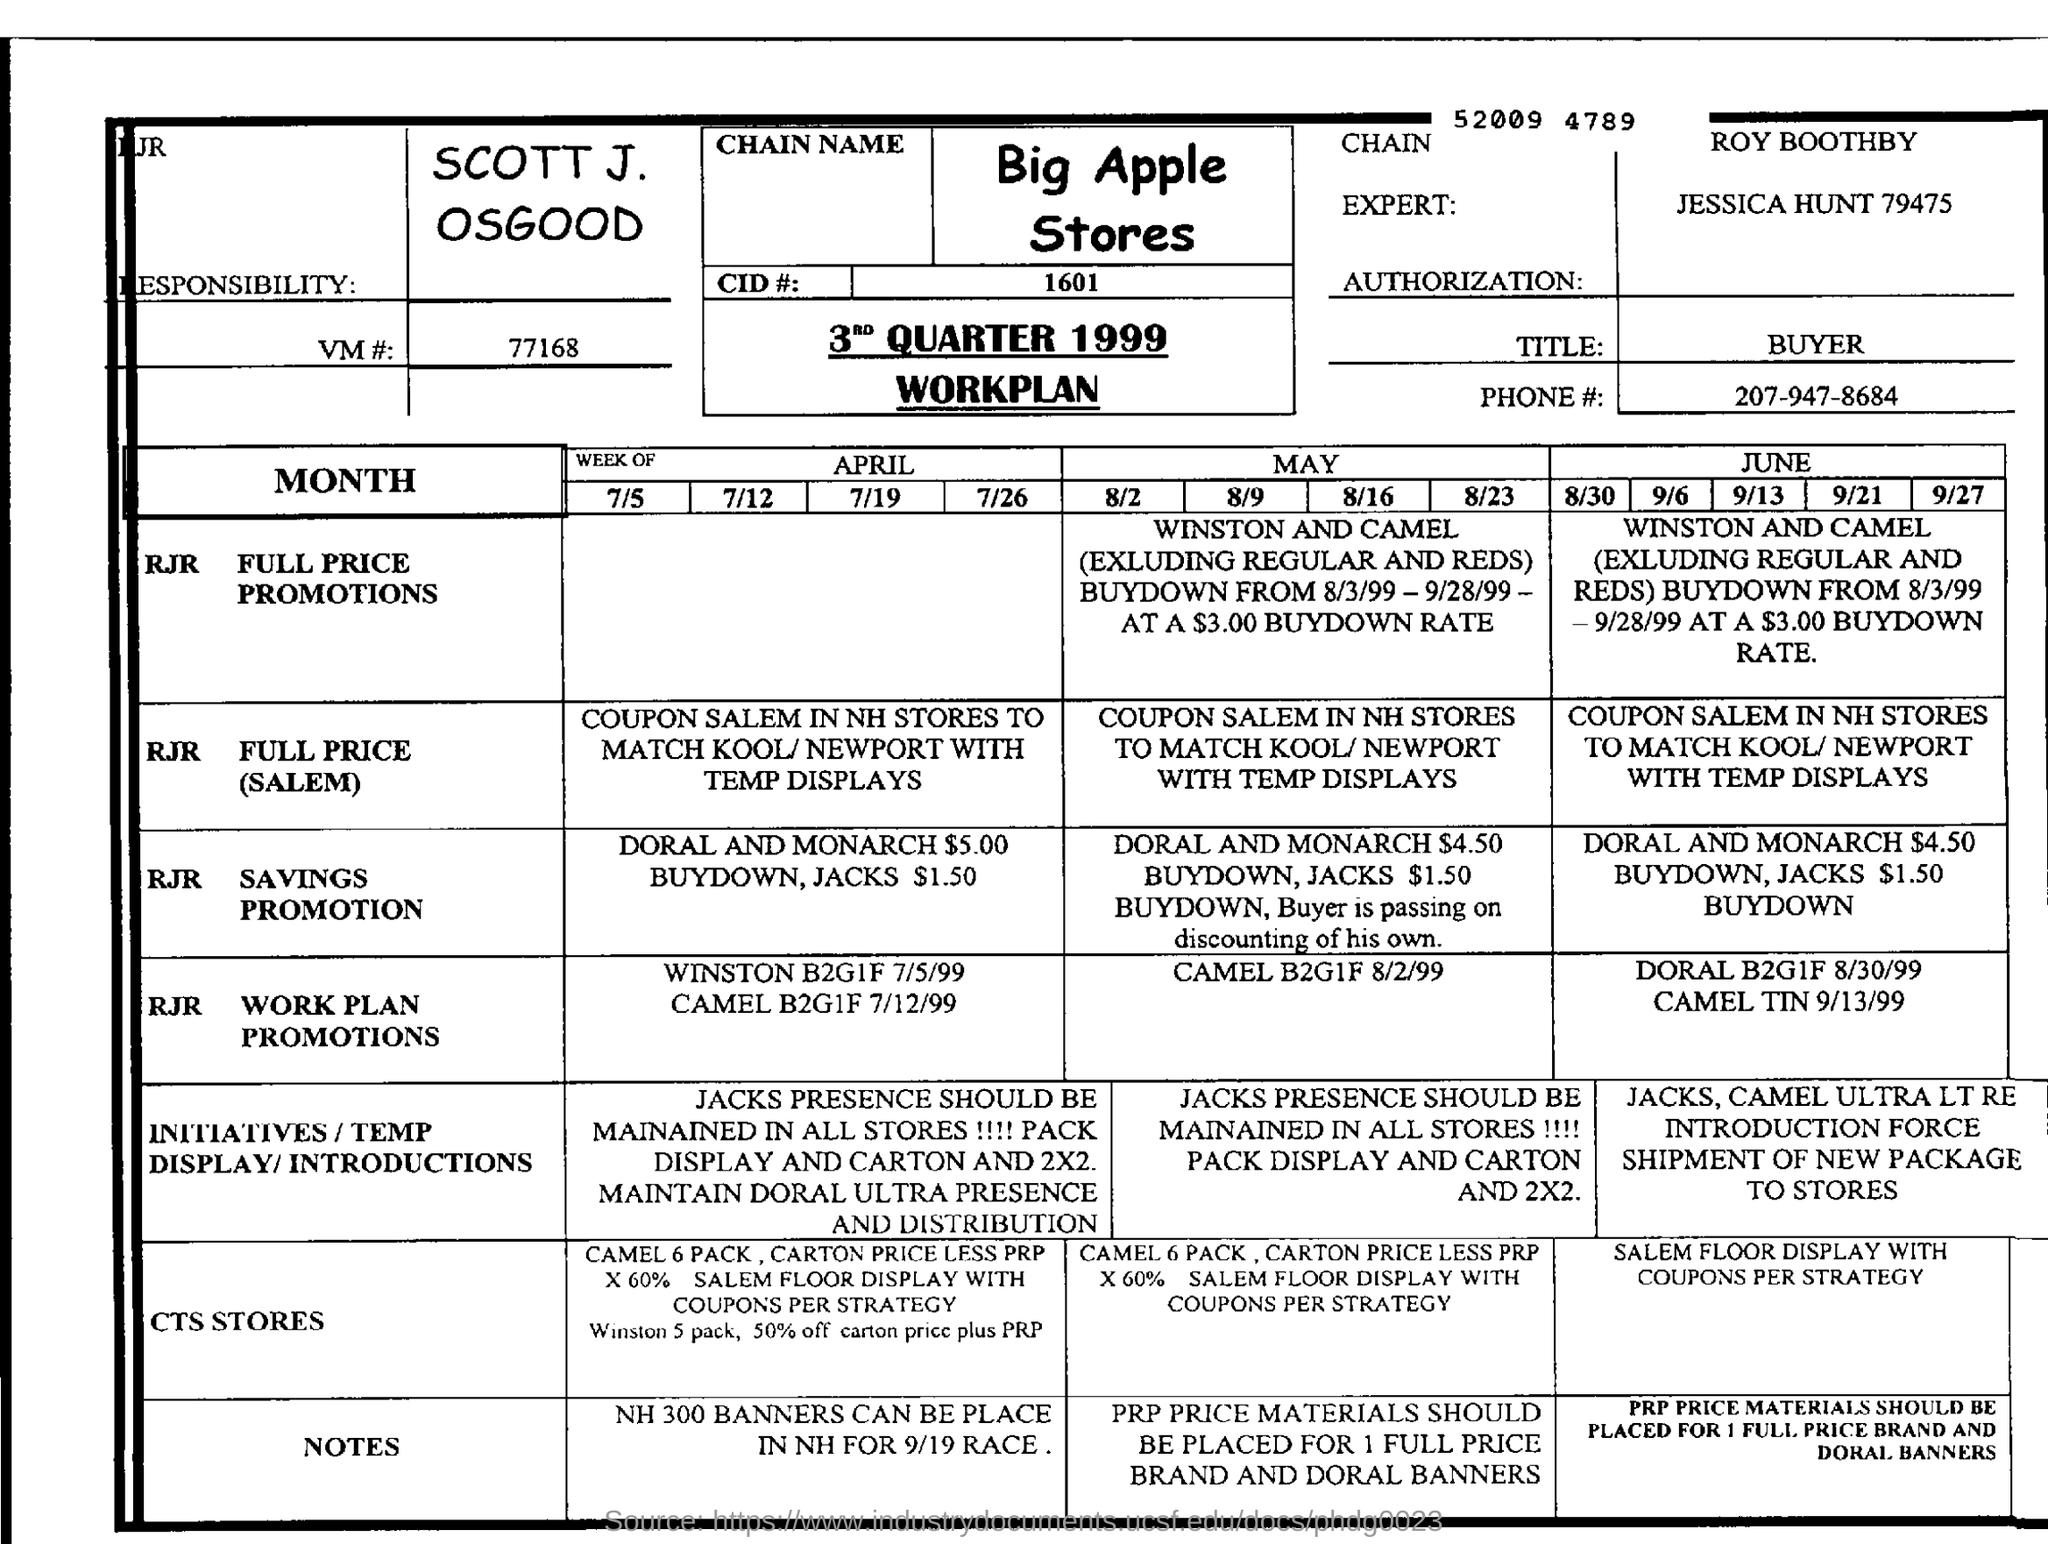What is the name of the Stores?
Your answer should be very brief. Big Apple Stores. What is the VM# mentioned in the form?
Your answer should be compact. 77168. What is the TITLE?
Offer a very short reply. Buyer. This document is the 3rd Quarter Workplan of which year?
Offer a terse response. 1999. 